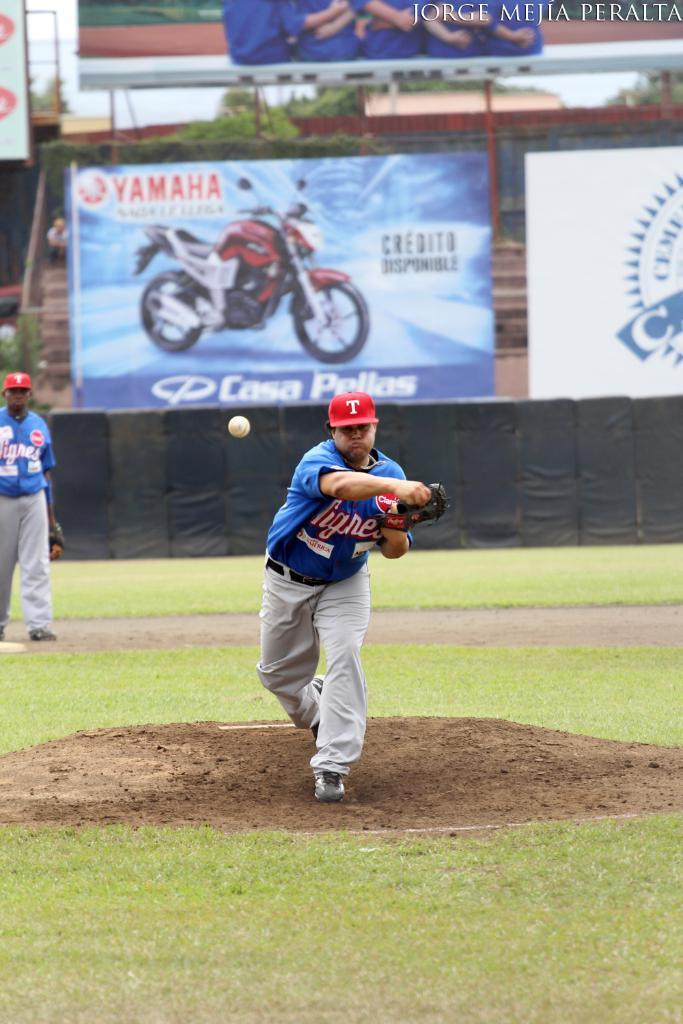<image>
Relay a brief, clear account of the picture shown. A baseball player is throwing a ball, wearing a uniform with Tigres on it and T on his cap, with Yamaha Plasa Pelias advertised on the sign. 